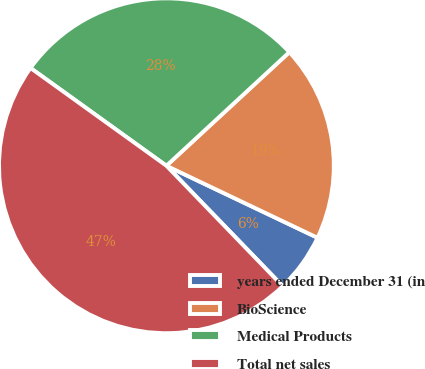Convert chart. <chart><loc_0><loc_0><loc_500><loc_500><pie_chart><fcel>years ended December 31 (in<fcel>BioScience<fcel>Medical Products<fcel>Total net sales<nl><fcel>5.7%<fcel>18.95%<fcel>28.2%<fcel>47.15%<nl></chart> 